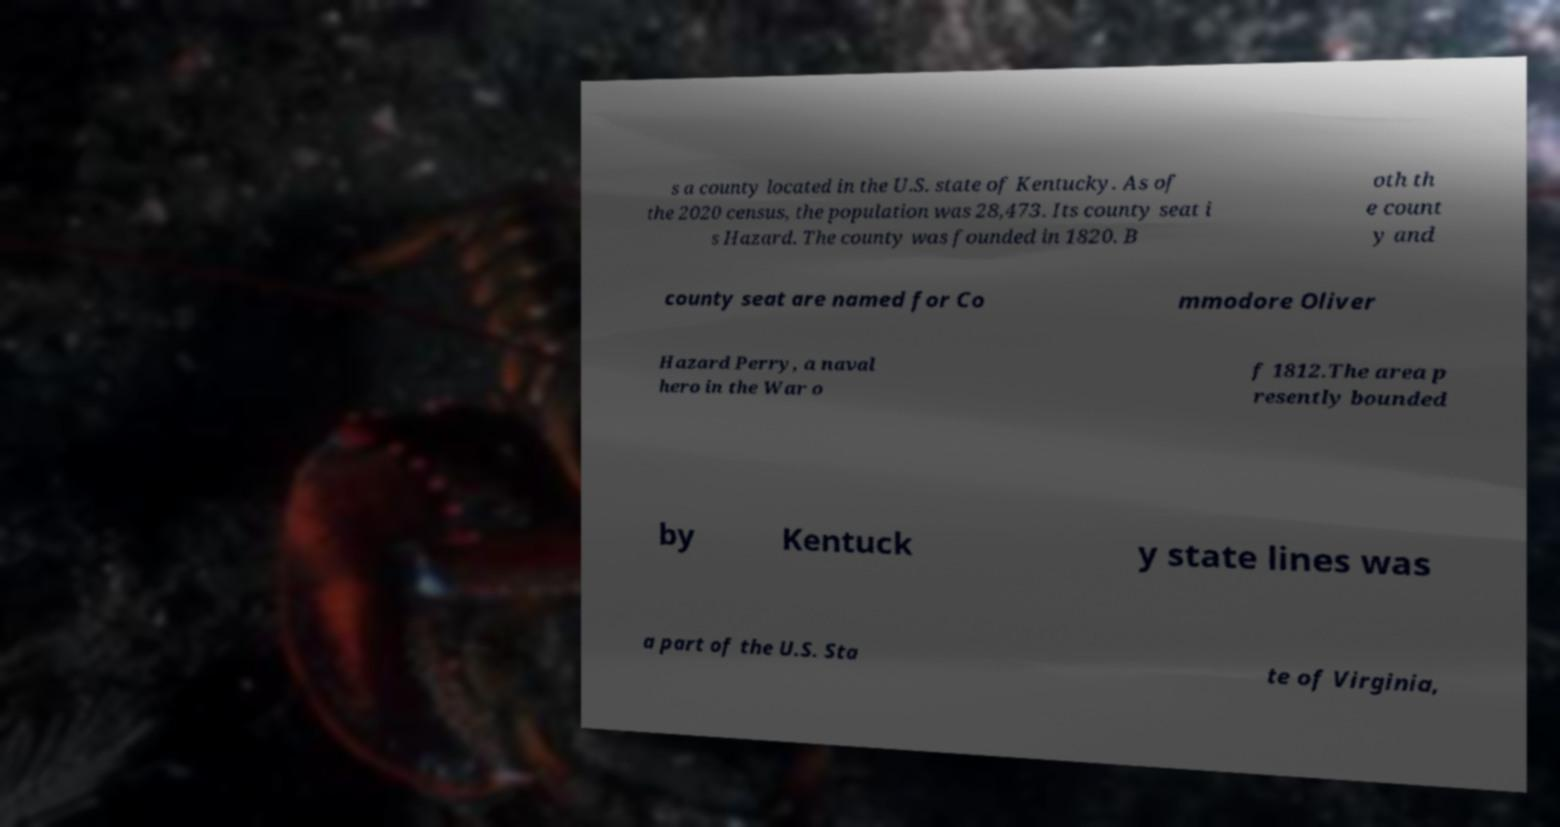Could you assist in decoding the text presented in this image and type it out clearly? s a county located in the U.S. state of Kentucky. As of the 2020 census, the population was 28,473. Its county seat i s Hazard. The county was founded in 1820. B oth th e count y and county seat are named for Co mmodore Oliver Hazard Perry, a naval hero in the War o f 1812.The area p resently bounded by Kentuck y state lines was a part of the U.S. Sta te of Virginia, 